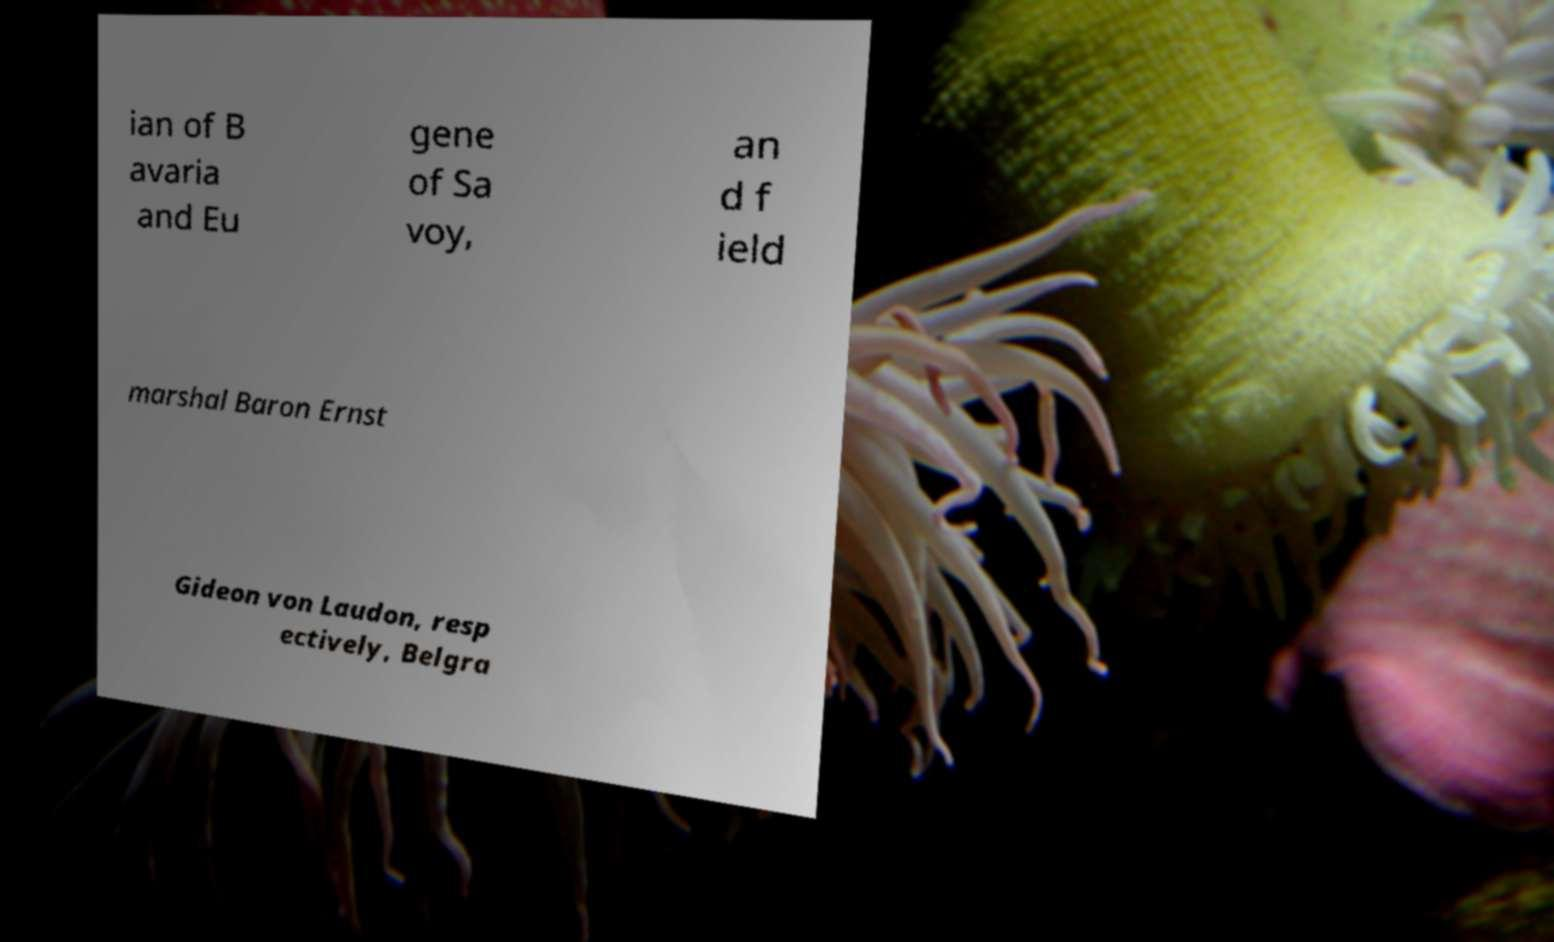Could you assist in decoding the text presented in this image and type it out clearly? ian of B avaria and Eu gene of Sa voy, an d f ield marshal Baron Ernst Gideon von Laudon, resp ectively, Belgra 